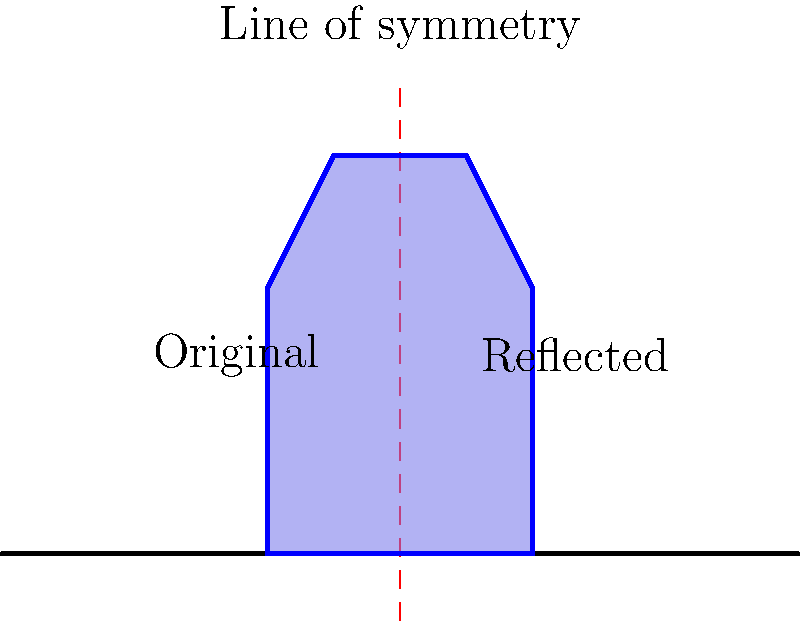A traditional Balinese temple design is reflected across a vertical line of symmetry. If the original temple's highest point is at coordinates $(0.5, 3)$, what are the coordinates of the highest point of the reflected temple? To find the coordinates of the highest point of the reflected temple, we need to follow these steps:

1. Identify the original coordinates: The highest point of the original temple is at $(0.5, 3)$.

2. Understand the reflection: The temple is being reflected across a vertical line of symmetry. This means that the $y$-coordinate will remain the same, but the $x$-coordinate will change.

3. Apply the reflection rule: For a vertical line of symmetry at $x = 0$, the reflection of a point $(x, y)$ is $(-x, y)$.

4. Calculate the new coordinates:
   - The $x$-coordinate: $0.5$ becomes $-0.5$
   - The $y$-coordinate: $3$ remains unchanged

5. Therefore, the highest point of the reflected temple will be at $(-0.5, 3)$.
Answer: $(-0.5, 3)$ 